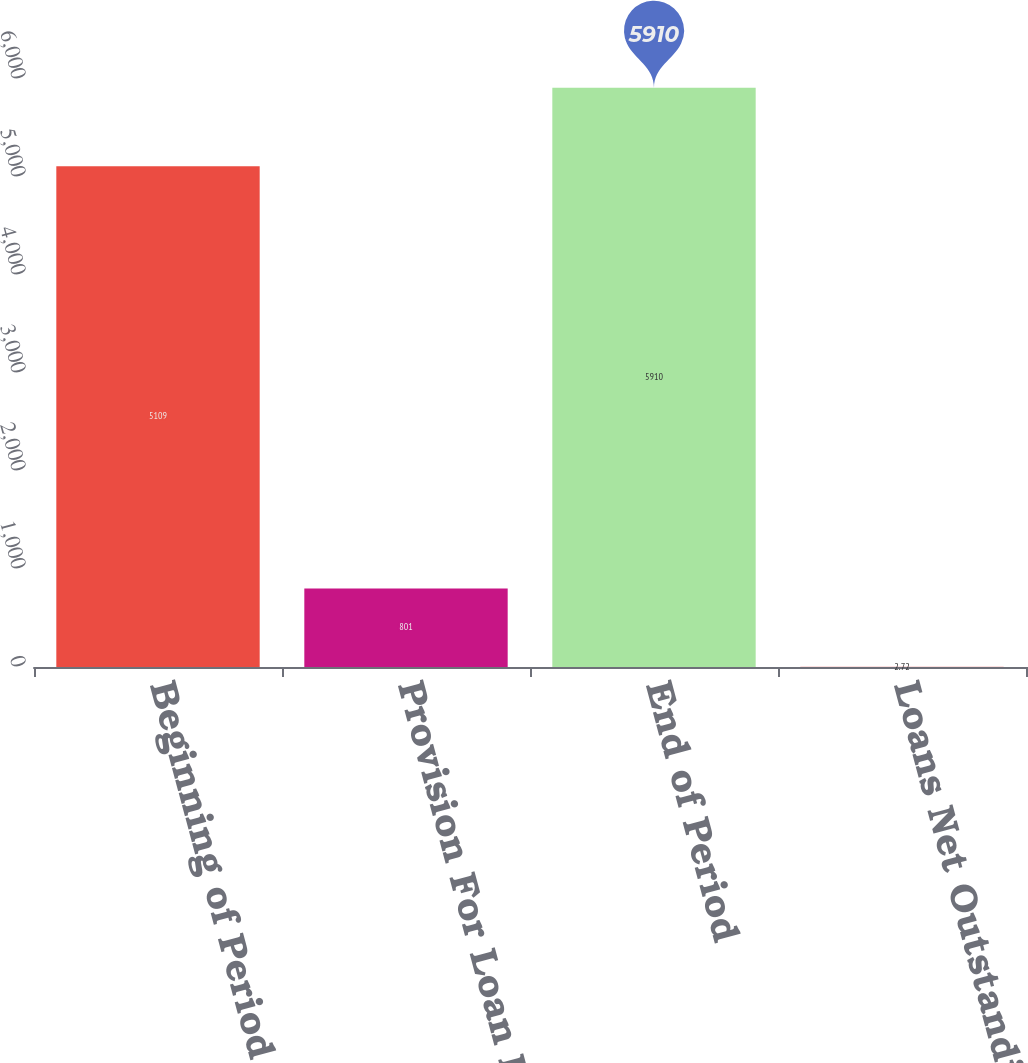<chart> <loc_0><loc_0><loc_500><loc_500><bar_chart><fcel>Beginning of Period<fcel>Provision For Loan Losses<fcel>End of Period<fcel>Loans Net Outstanding<nl><fcel>5109<fcel>801<fcel>5910<fcel>2.72<nl></chart> 